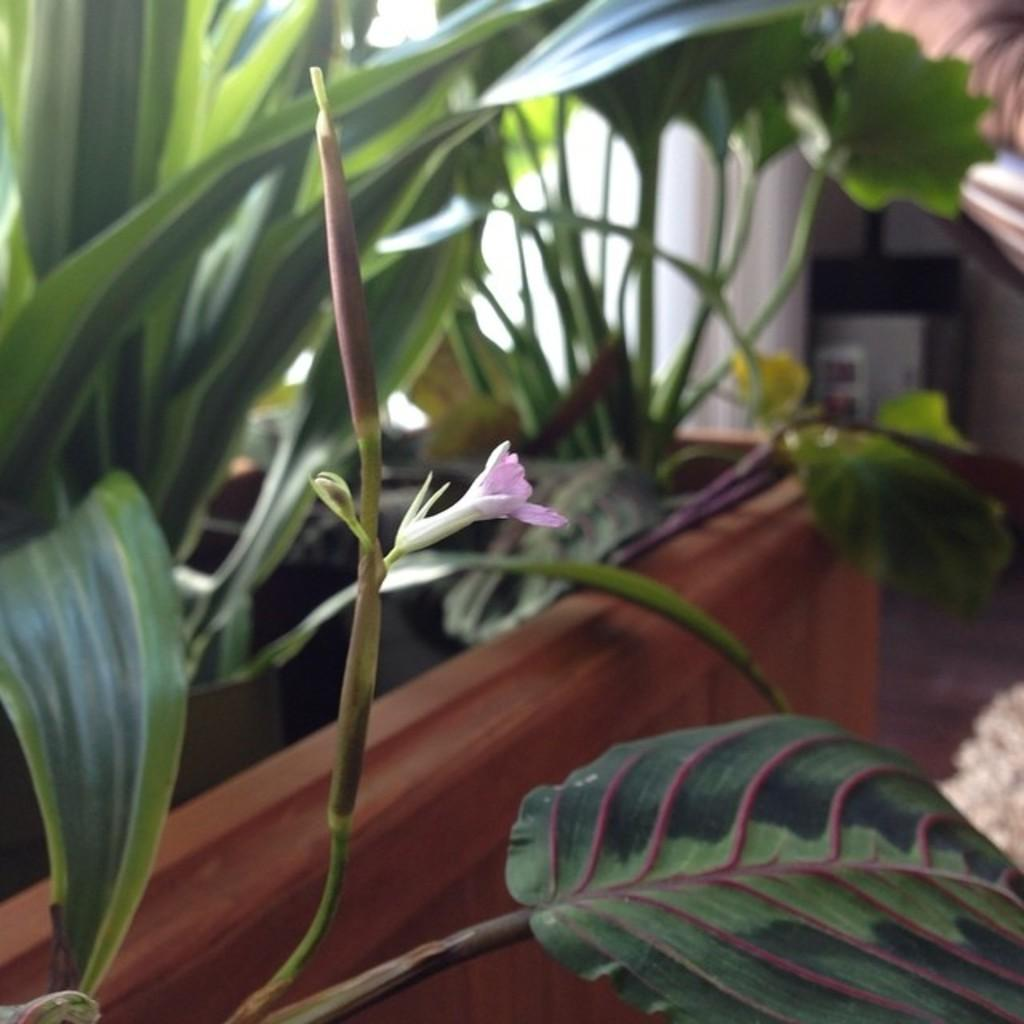What colors are the flowers in the image? The flowers in the image are pink and yellow. What are the flowers growing on? The flowers are on plants. How are the plants arranged in the image? The plants are in pots. What can be seen in the background of the image? There is an object visible at the back of the image. Can you tell me how the crow is helping the stranger in the image? There is no crow or stranger present in the image. 